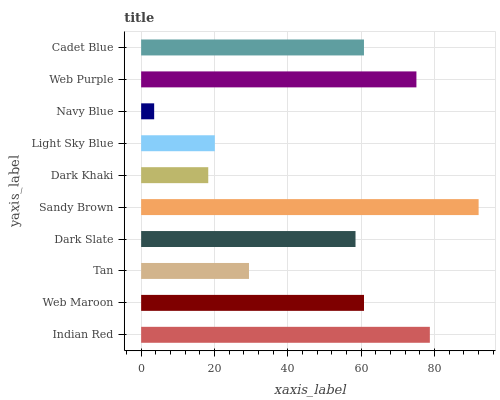Is Navy Blue the minimum?
Answer yes or no. Yes. Is Sandy Brown the maximum?
Answer yes or no. Yes. Is Web Maroon the minimum?
Answer yes or no. No. Is Web Maroon the maximum?
Answer yes or no. No. Is Indian Red greater than Web Maroon?
Answer yes or no. Yes. Is Web Maroon less than Indian Red?
Answer yes or no. Yes. Is Web Maroon greater than Indian Red?
Answer yes or no. No. Is Indian Red less than Web Maroon?
Answer yes or no. No. Is Cadet Blue the high median?
Answer yes or no. Yes. Is Dark Slate the low median?
Answer yes or no. Yes. Is Web Purple the high median?
Answer yes or no. No. Is Indian Red the low median?
Answer yes or no. No. 